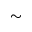Convert formula to latex. <formula><loc_0><loc_0><loc_500><loc_500>\sim</formula> 